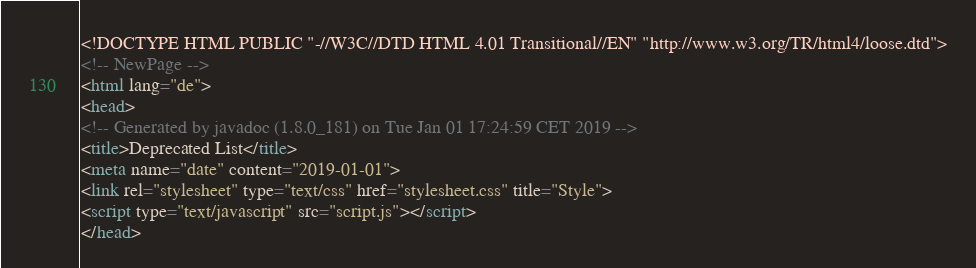Convert code to text. <code><loc_0><loc_0><loc_500><loc_500><_HTML_><!DOCTYPE HTML PUBLIC "-//W3C//DTD HTML 4.01 Transitional//EN" "http://www.w3.org/TR/html4/loose.dtd">
<!-- NewPage -->
<html lang="de">
<head>
<!-- Generated by javadoc (1.8.0_181) on Tue Jan 01 17:24:59 CET 2019 -->
<title>Deprecated List</title>
<meta name="date" content="2019-01-01">
<link rel="stylesheet" type="text/css" href="stylesheet.css" title="Style">
<script type="text/javascript" src="script.js"></script>
</head></code> 